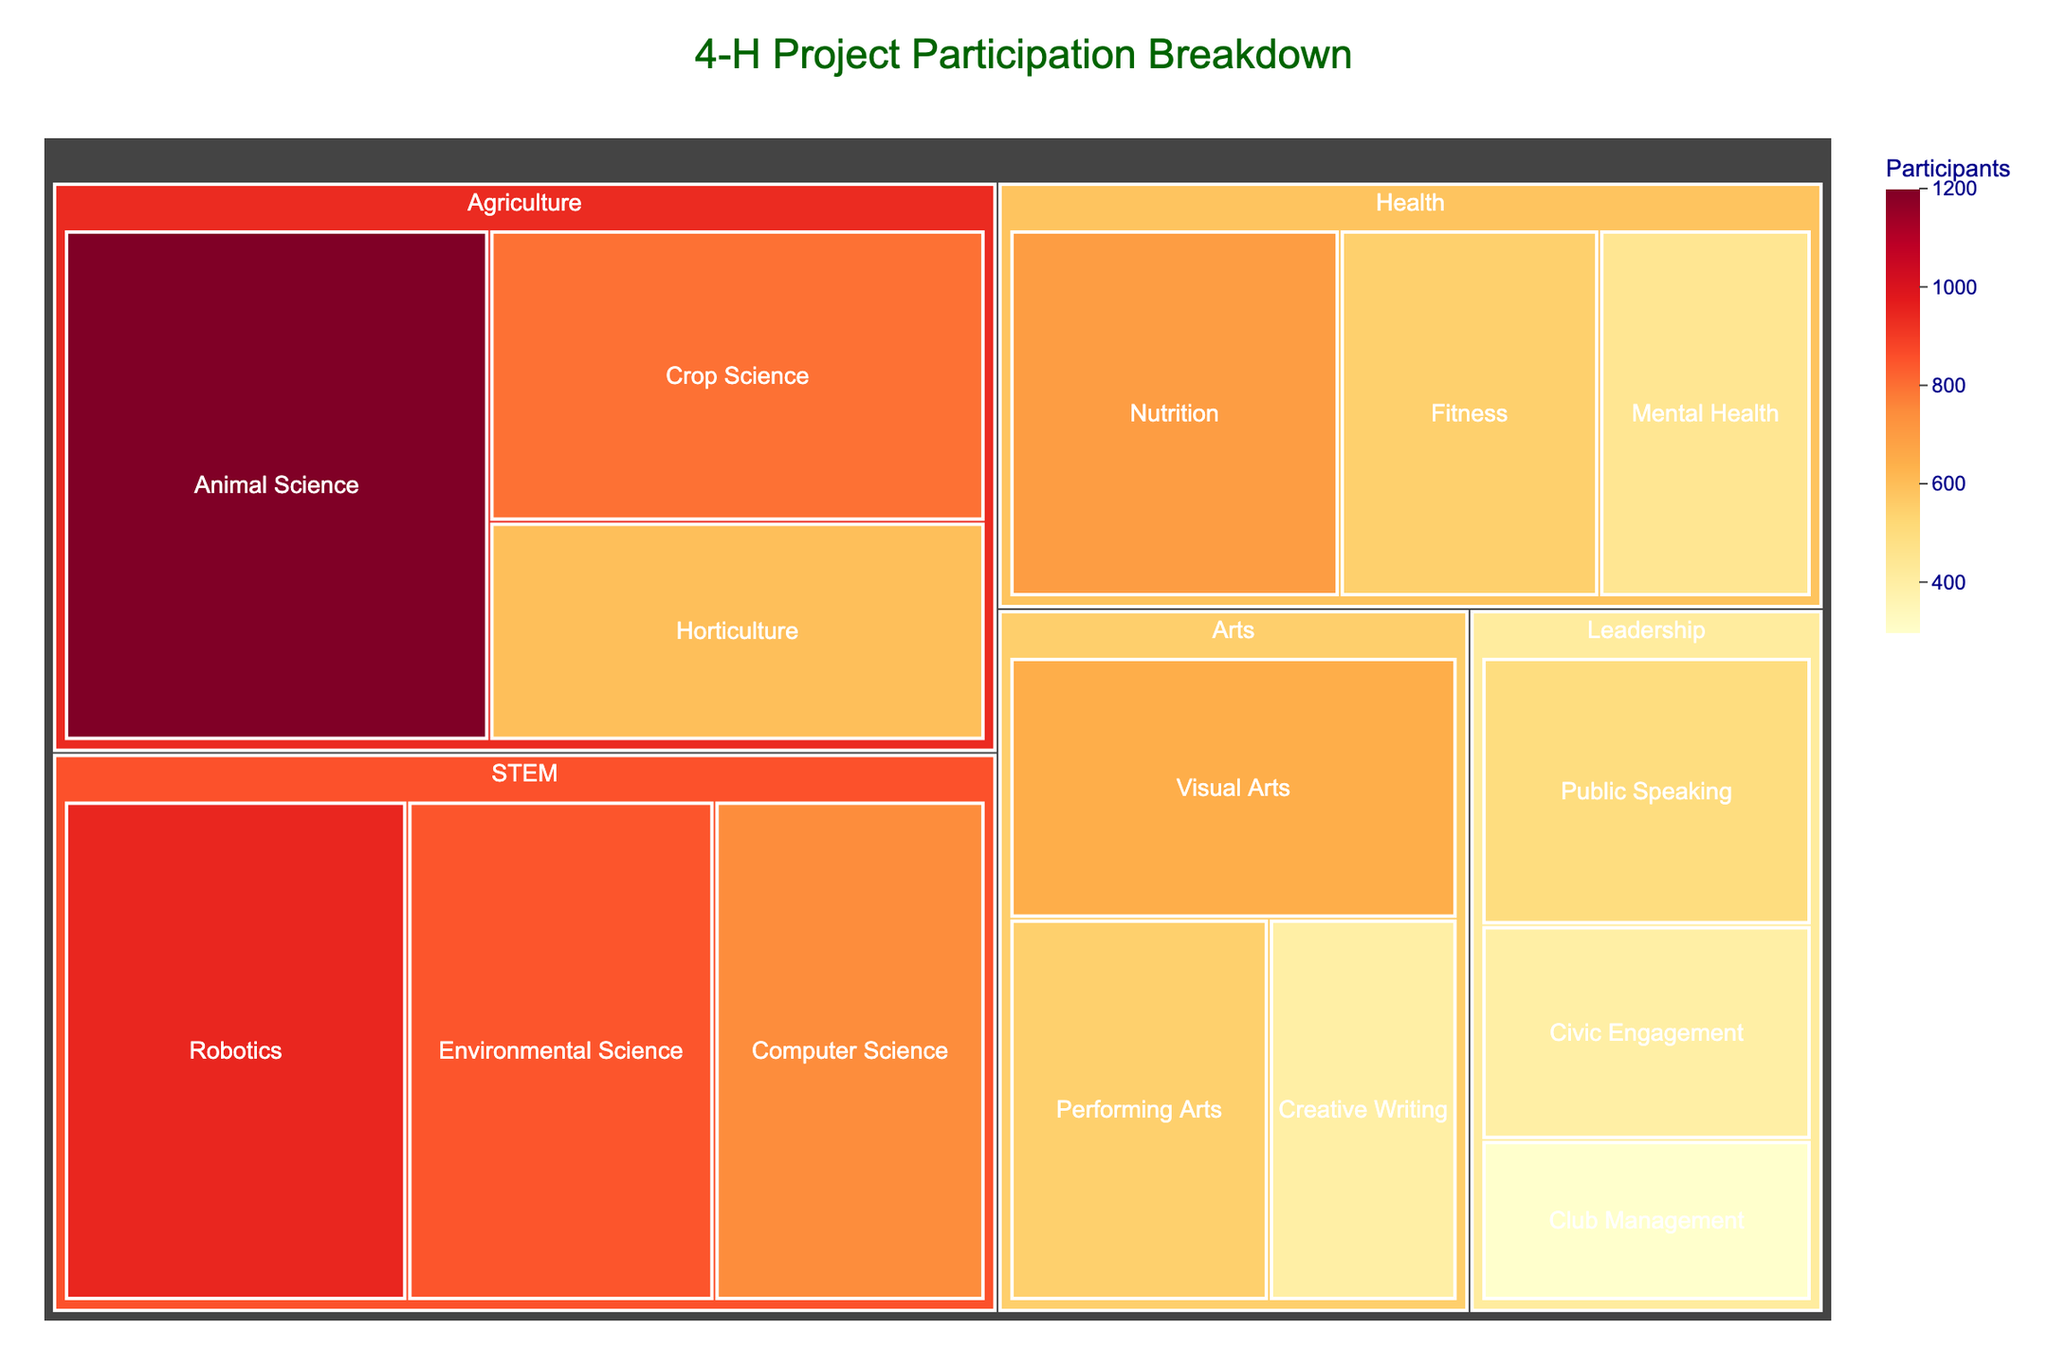What is the title of the treemap? The title is displayed at the top center of the treemap, and it reads '4-H Project Participation Breakdown'.
Answer: 4-H Project Participation Breakdown Which subcategory has the most participants? From the treemap color intensity and size, 'Animal Science' in the 'Agriculture' category has the highest number of participants, which is 1200.
Answer: Animal Science Which category has the fewest participants overall? By examining the color intensity and area of each category, 'Leadership' appears smaller in size and lighter in color. To confirm, sum the participants: Public Speaking (500) + Civic Engagement (400) + Club Management (300) = 1200. This is less than any other category.
Answer: Leadership How many participants are in the 'STEM' category? Add the participants in each STEM subcategory: Robotics (950) + Computer Science (750) + Environmental Science (850). The total is 950 + 750 + 850 = 2550.
Answer: 2550 Compare the number of participants in 'Visual Arts' to 'Creative Writing'. Which has more, and by how much? 'Visual Arts' has 650 participants while 'Creative Writing' has 400. The difference is 650 - 400 = 250 participants.
Answer: Visual Arts by 250 What is the average number of participants per subcategory in 'Health'? The subcategories in 'Health' are: Nutrition (700), Fitness (550), and Mental Health (450). The average is (700 + 550 + 450) / 3 = 1700 / 3 ≈ 567.
Answer: 567 Which subcategory has more participants, 'Crop Science' or 'Environmental Science'? By comparing both subcategories, 'Crop Science' has 800 participants and 'Environmental Science' has 850. Therefore, 'Environmental Science' has more participants.
Answer: Environmental Science What fraction of the total participants are involved in 'Arts'? First, sum the participants in the 'Arts' category: Visual Arts (650) + Performing Arts (550) + Creative Writing (400) = 1600. Then divide by the total participants in all categories. Total participants: 1200 + 800 + 600 + 950 + 750 + 850 + 700 + 550 + 450 + 500 + 400 + 300 + 650 + 550 + 400 = 8650. The fraction is 1600 / 8650 ≈ 0.185.
Answer: 0.185 Which category's subcategories have the widest range of participant numbers? Find the range for each category:
- Agriculture: max (1200) - min (600) = 600
- STEM: max (950) - min (750) = 200
- Health: max (700) - min (450) = 250
- Leadership: max (500) - min (300) = 200
- Arts: max (650) - min (400) = 250
'Agriculture' with a range of 600 has the widest range of participants.
Answer: Agriculture How many participants more are there in 'Animal Science' compared to 'Fitness'? 'Animal Science' has 1200 participants, and 'Fitness' has 550 participants. The difference is 1200 - 550 = 650.
Answer: 650 